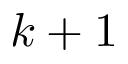Convert formula to latex. <formula><loc_0><loc_0><loc_500><loc_500>k + 1</formula> 